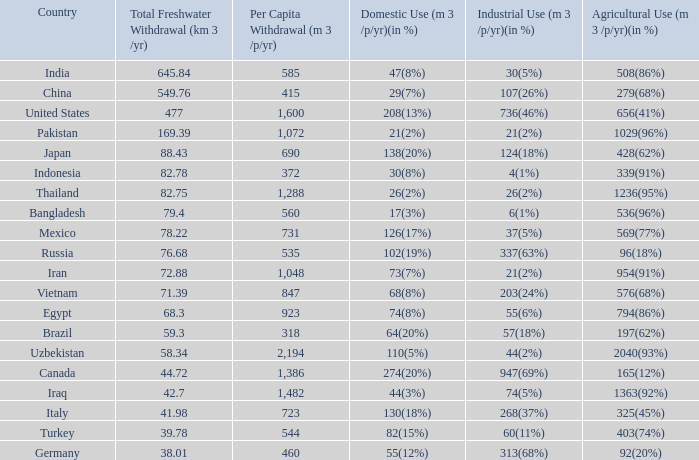What is the average Total Freshwater Withdrawal (km 3 /yr), when Industrial Use (m 3 /p/yr)(in %) is 337(63%), and when Per Capita Withdrawal (m 3 /p/yr) is greater than 535? None. Would you mind parsing the complete table? {'header': ['Country', 'Total Freshwater Withdrawal (km 3 /yr)', 'Per Capita Withdrawal (m 3 /p/yr)', 'Domestic Use (m 3 /p/yr)(in %)', 'Industrial Use (m 3 /p/yr)(in %)', 'Agricultural Use (m 3 /p/yr)(in %)'], 'rows': [['India', '645.84', '585', '47(8%)', '30(5%)', '508(86%)'], ['China', '549.76', '415', '29(7%)', '107(26%)', '279(68%)'], ['United States', '477', '1,600', '208(13%)', '736(46%)', '656(41%)'], ['Pakistan', '169.39', '1,072', '21(2%)', '21(2%)', '1029(96%)'], ['Japan', '88.43', '690', '138(20%)', '124(18%)', '428(62%)'], ['Indonesia', '82.78', '372', '30(8%)', '4(1%)', '339(91%)'], ['Thailand', '82.75', '1,288', '26(2%)', '26(2%)', '1236(95%)'], ['Bangladesh', '79.4', '560', '17(3%)', '6(1%)', '536(96%)'], ['Mexico', '78.22', '731', '126(17%)', '37(5%)', '569(77%)'], ['Russia', '76.68', '535', '102(19%)', '337(63%)', '96(18%)'], ['Iran', '72.88', '1,048', '73(7%)', '21(2%)', '954(91%)'], ['Vietnam', '71.39', '847', '68(8%)', '203(24%)', '576(68%)'], ['Egypt', '68.3', '923', '74(8%)', '55(6%)', '794(86%)'], ['Brazil', '59.3', '318', '64(20%)', '57(18%)', '197(62%)'], ['Uzbekistan', '58.34', '2,194', '110(5%)', '44(2%)', '2040(93%)'], ['Canada', '44.72', '1,386', '274(20%)', '947(69%)', '165(12%)'], ['Iraq', '42.7', '1,482', '44(3%)', '74(5%)', '1363(92%)'], ['Italy', '41.98', '723', '130(18%)', '268(37%)', '325(45%)'], ['Turkey', '39.78', '544', '82(15%)', '60(11%)', '403(74%)'], ['Germany', '38.01', '460', '55(12%)', '313(68%)', '92(20%)']]} 